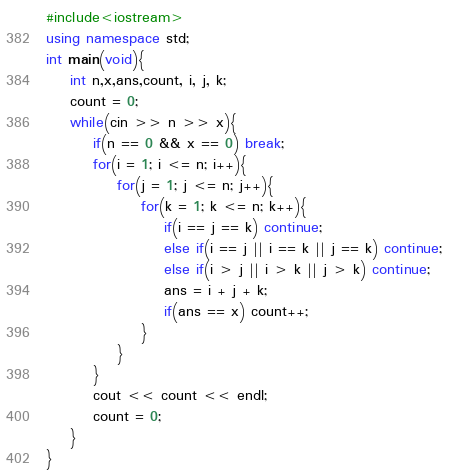<code> <loc_0><loc_0><loc_500><loc_500><_C++_>#include<iostream>
using namespace std;
int main(void){
    int n,x,ans,count, i, j, k;
    count = 0;
    while(cin >> n >> x){
        if(n == 0 && x == 0) break;
        for(i = 1; i <= n; i++){
            for(j = 1; j <= n; j++){
                for(k = 1; k <= n; k++){
                    if(i == j == k) continue;
                    else if(i == j || i == k || j == k) continue;    
                    else if(i > j || i > k || j > k) continue;
                    ans = i + j + k;
                    if(ans == x) count++;
                }
            }
        }
        cout << count << endl;
        count = 0;
    }
}
</code> 